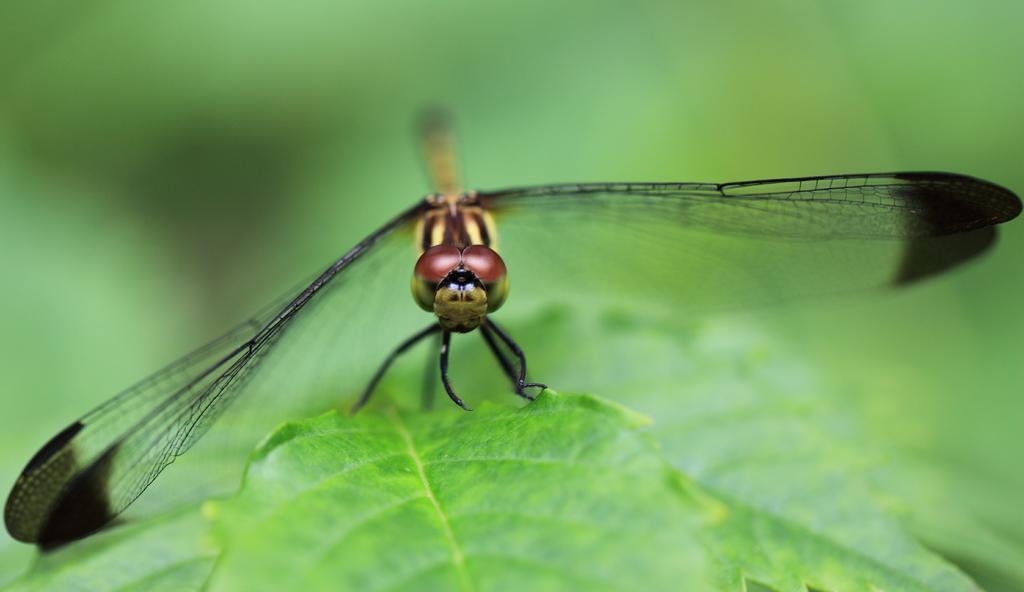In one or two sentences, can you explain what this image depicts? In this picture I can see there is an insect and it has wings and there is a leaf. The backdrop is blurred. 